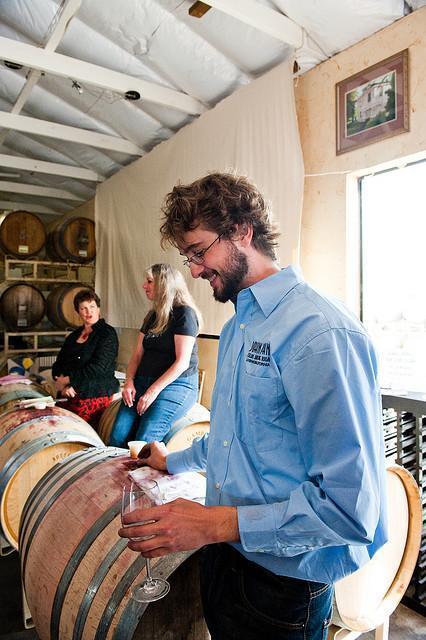How many people are in the picture?
Give a very brief answer. 3. 